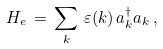Convert formula to latex. <formula><loc_0><loc_0><loc_500><loc_500>H _ { e } \, = \, \sum _ { k } \, \varepsilon ( { k } ) \, a ^ { \dag } _ { k } a _ { k } \, ,</formula> 